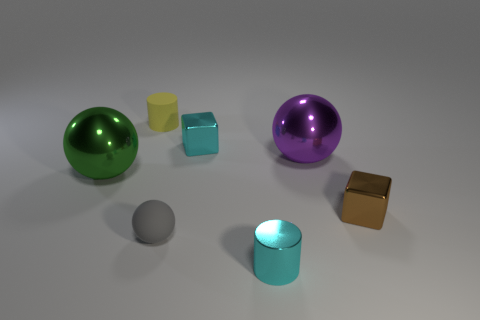Do the big object to the left of the yellow matte cylinder and the rubber object in front of the yellow cylinder have the same shape?
Your answer should be very brief. Yes. What is the cube that is behind the large green ball made of?
Offer a terse response. Metal. What size is the shiny object that is the same color as the tiny shiny cylinder?
Keep it short and to the point. Small. What number of objects are either small things left of the large purple shiny ball or cyan metallic cylinders?
Your answer should be very brief. 4. Are there an equal number of purple metal things that are in front of the green metal object and yellow rubber objects?
Provide a succinct answer. No. Does the green object have the same size as the yellow cylinder?
Make the answer very short. No. The shiny cylinder that is the same size as the gray object is what color?
Offer a terse response. Cyan. Is the size of the brown metallic cube the same as the cylinder that is behind the tiny cyan cube?
Your answer should be very brief. Yes. What number of blocks have the same color as the small metallic cylinder?
Give a very brief answer. 1. What number of things are either gray metallic balls or metal objects that are to the left of the yellow matte cylinder?
Keep it short and to the point. 1. 